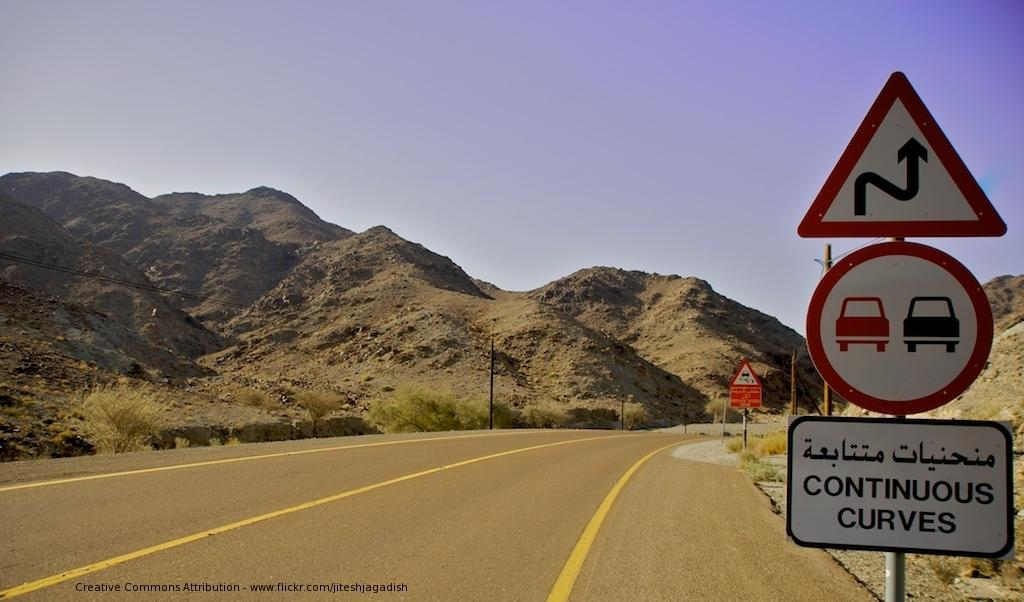<image>
Offer a succinct explanation of the picture presented. a sign that has the word continuous curves on it 